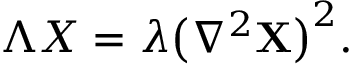<formula> <loc_0><loc_0><loc_500><loc_500>\begin{array} { r } { \Lambda X = \lambda \left ( \nabla ^ { 2 } X \right ) ^ { 2 } . } \end{array}</formula> 